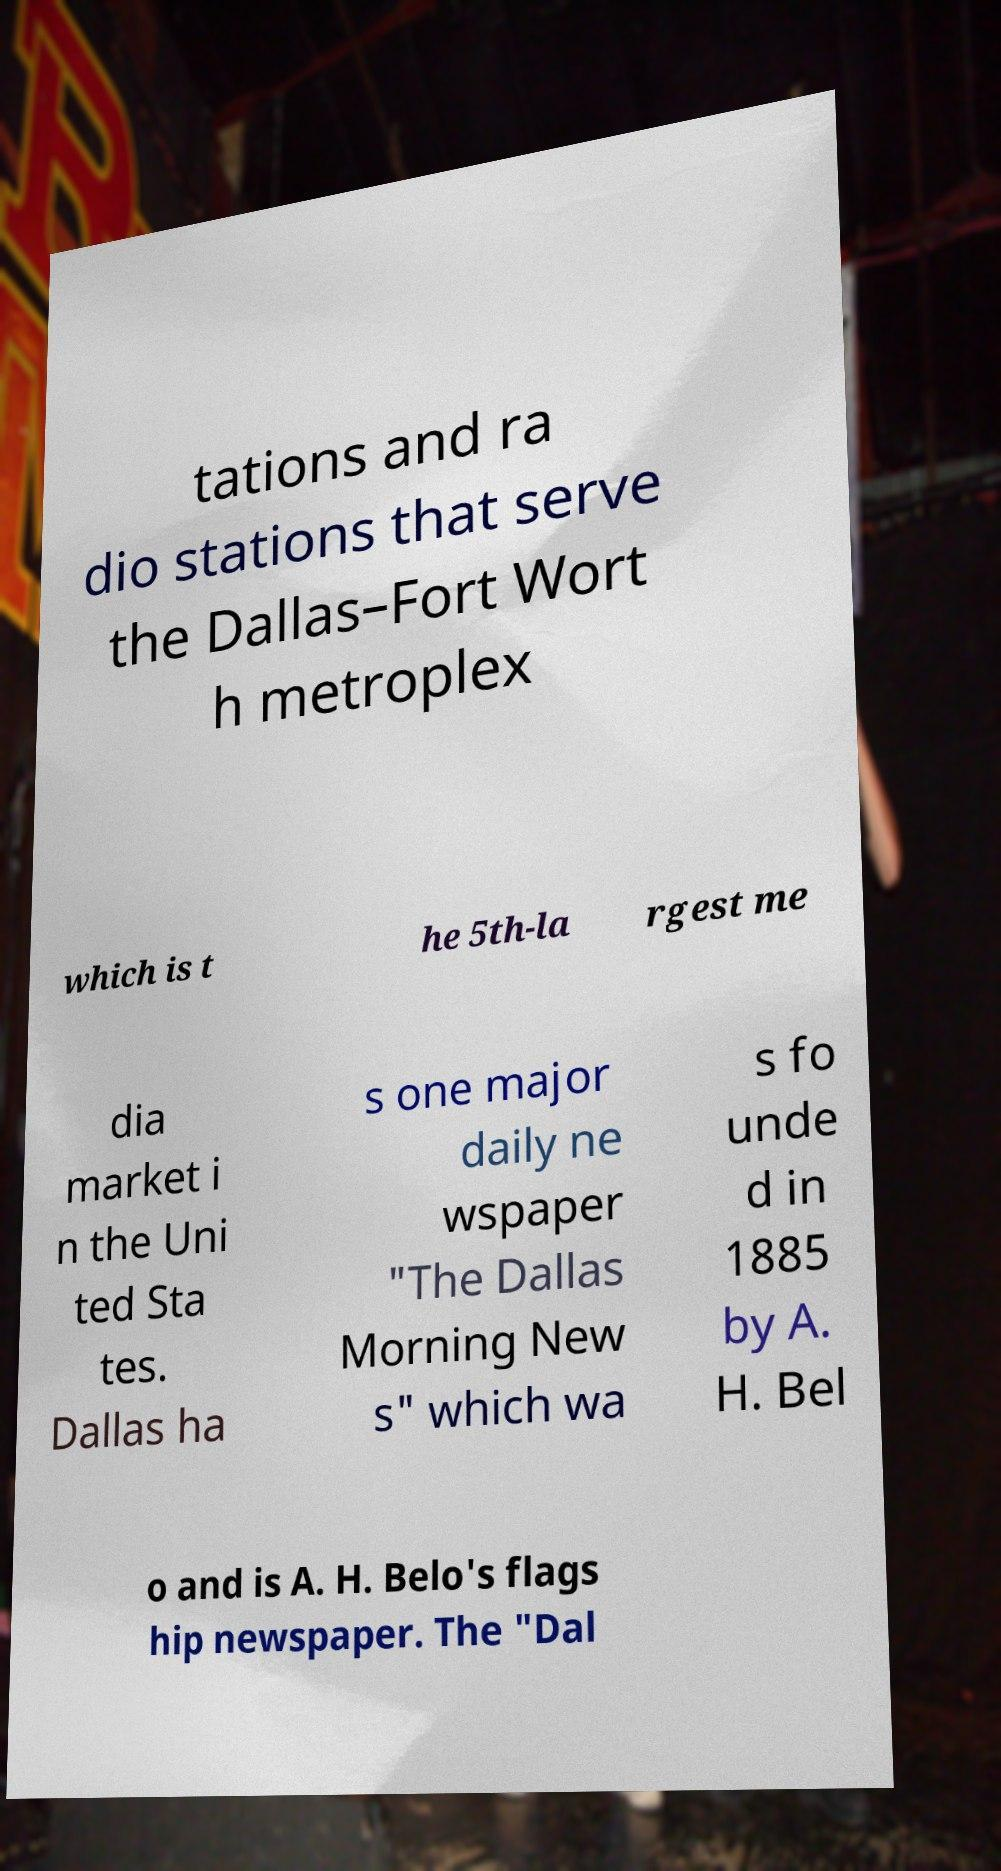For documentation purposes, I need the text within this image transcribed. Could you provide that? tations and ra dio stations that serve the Dallas–Fort Wort h metroplex which is t he 5th-la rgest me dia market i n the Uni ted Sta tes. Dallas ha s one major daily ne wspaper "The Dallas Morning New s" which wa s fo unde d in 1885 by A. H. Bel o and is A. H. Belo's flags hip newspaper. The "Dal 